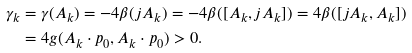Convert formula to latex. <formula><loc_0><loc_0><loc_500><loc_500>\gamma _ { k } & = \gamma ( A _ { k } ) = - 4 \beta ( j A _ { k } ) = - 4 \beta ( [ A _ { k } , j A _ { k } ] ) = 4 \beta ( [ j A _ { k } , A _ { k } ] ) \\ & = 4 g ( A _ { k } \cdot p _ { 0 } , A _ { k } \cdot p _ { 0 } ) > 0 .</formula> 